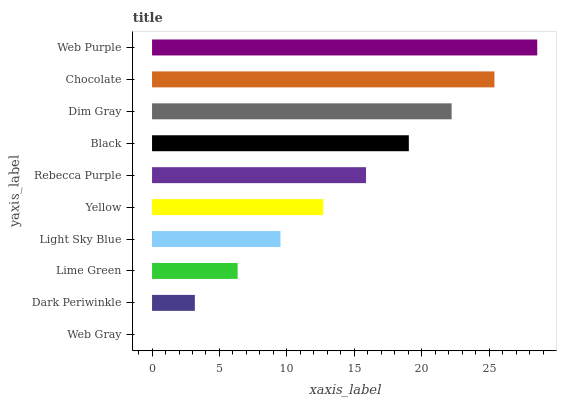Is Web Gray the minimum?
Answer yes or no. Yes. Is Web Purple the maximum?
Answer yes or no. Yes. Is Dark Periwinkle the minimum?
Answer yes or no. No. Is Dark Periwinkle the maximum?
Answer yes or no. No. Is Dark Periwinkle greater than Web Gray?
Answer yes or no. Yes. Is Web Gray less than Dark Periwinkle?
Answer yes or no. Yes. Is Web Gray greater than Dark Periwinkle?
Answer yes or no. No. Is Dark Periwinkle less than Web Gray?
Answer yes or no. No. Is Rebecca Purple the high median?
Answer yes or no. Yes. Is Yellow the low median?
Answer yes or no. Yes. Is Black the high median?
Answer yes or no. No. Is Lime Green the low median?
Answer yes or no. No. 